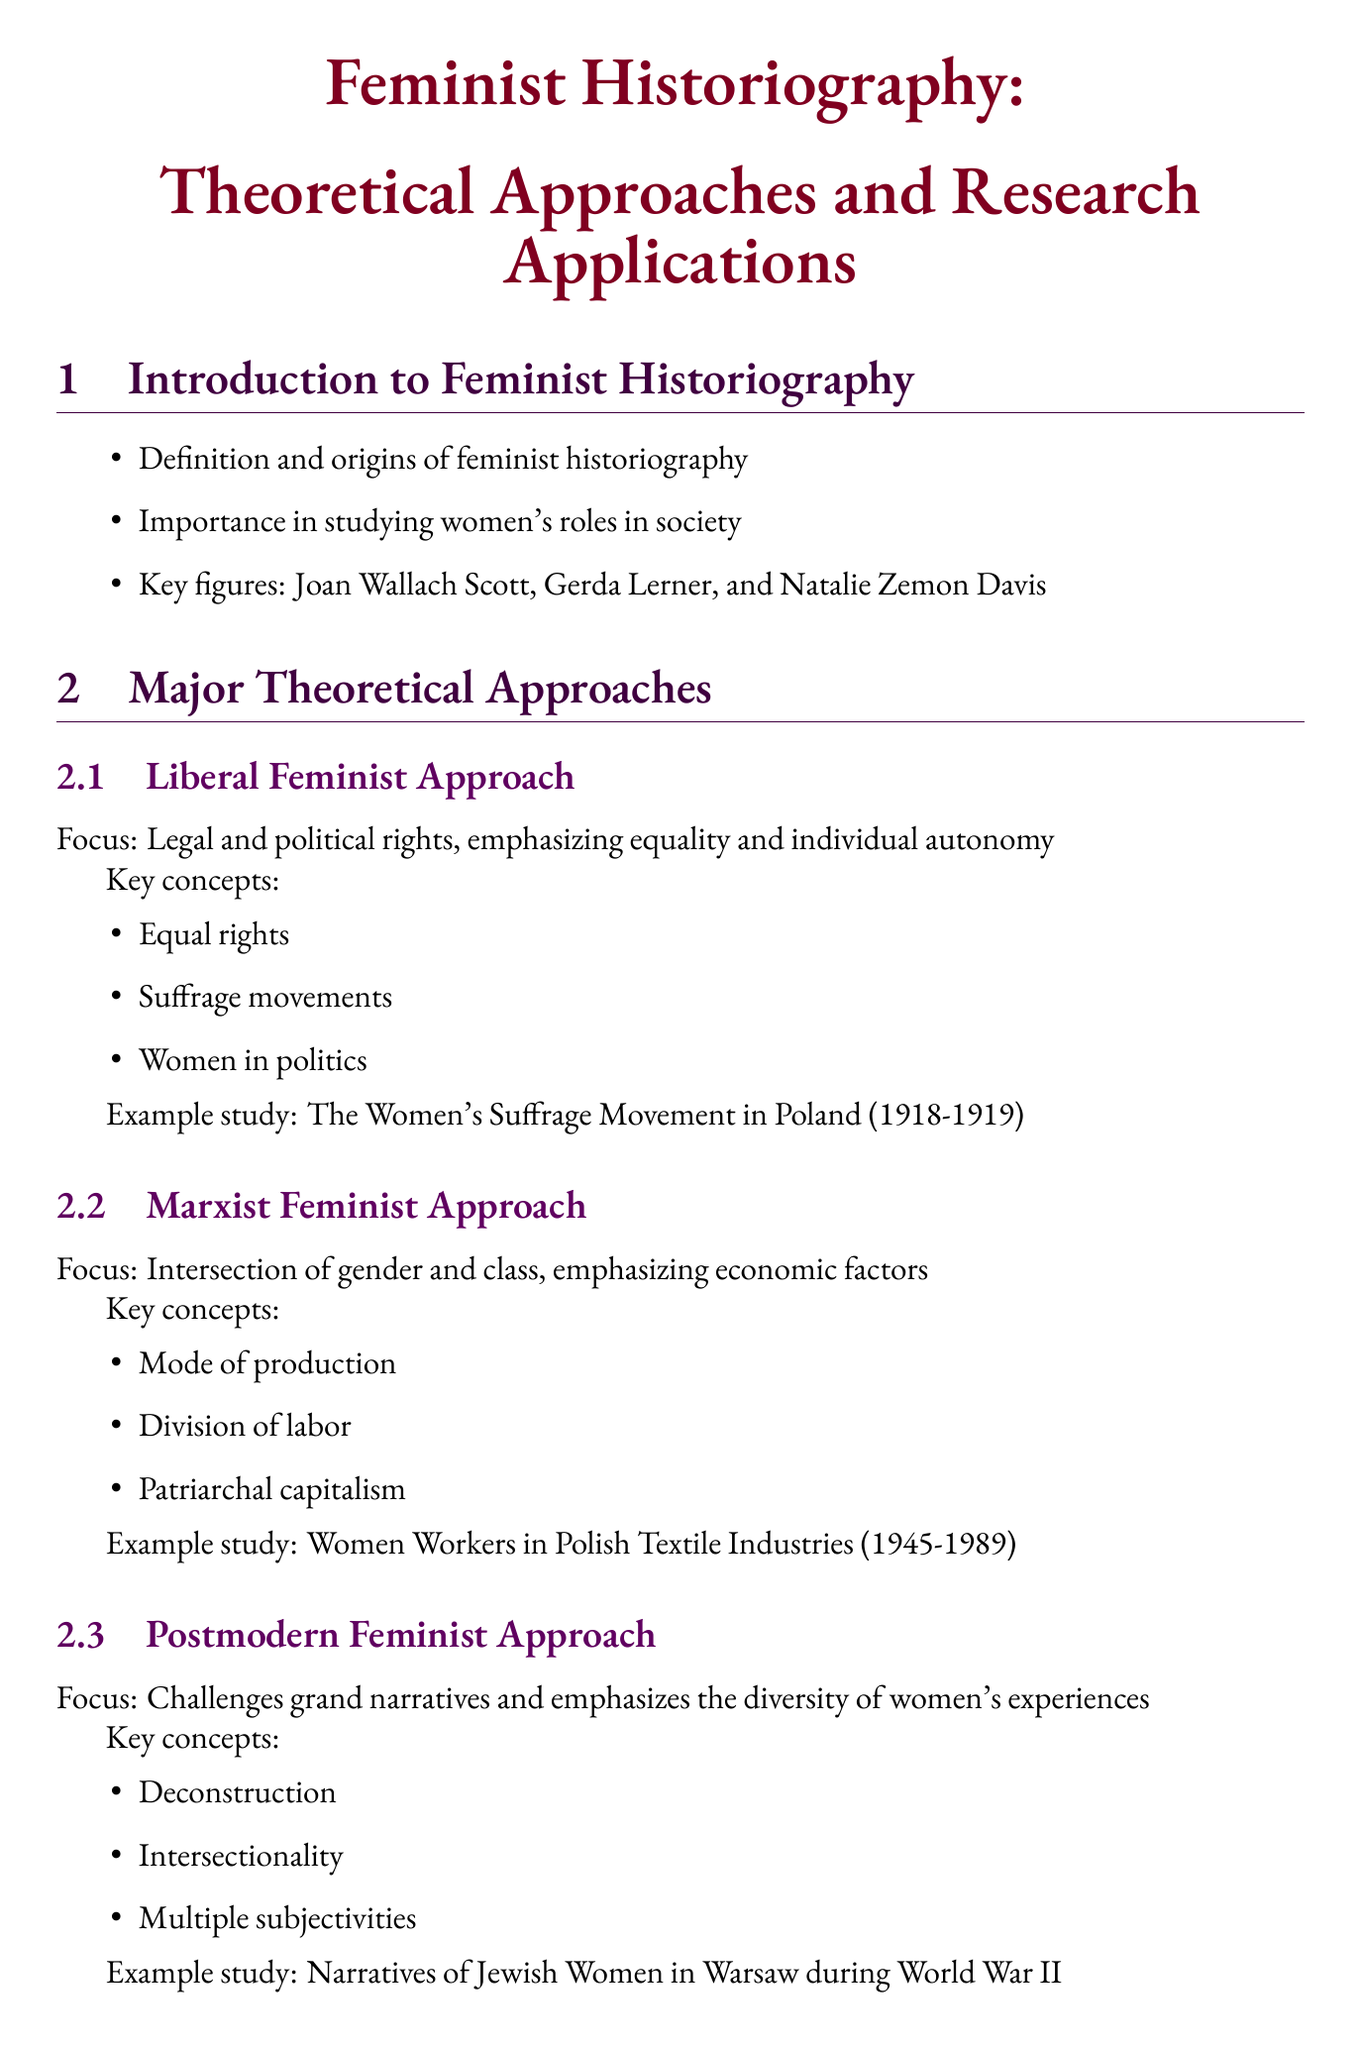What is feminist historiography? Feminist historiography is defined and its origins discussed in the document.
Answer: Definition and origins of feminist historiography Who are key figures mentioned in the guide? The document lists important contributors to feminist historiography.
Answer: Joan Wallach Scott, Gerda Lerner, and Natalie Zemon Davis What is the focus of the Marxist feminist approach? The document provides a description of the theoretical approaches and their focus areas.
Answer: Intersection of gender and class What study exemplifies the postmodern feminist approach? An example study is given to illustrate the application of different feminist approaches in research.
Answer: Narratives of Jewish Women in Warsaw during World War II How many case studies in Polish women's history are mentioned? The document lists distinct case studies under a specific section.
Answer: Three What method is used in research methodologies alongside oral history? The document outlines various research methodologies used in feminist historiography.
Answer: Archival research and document analysis What is a challenge noted in feminist historiography? The document discusses challenges and debates within the field of feminist historiography.
Answer: Representation and voice What is the name of the journal for further study? The document lists resources for further study, including a specific journal.
Answer: Aspasia: The International Yearbook of Central, Eastern, and Southeastern European Women's and Gender History 